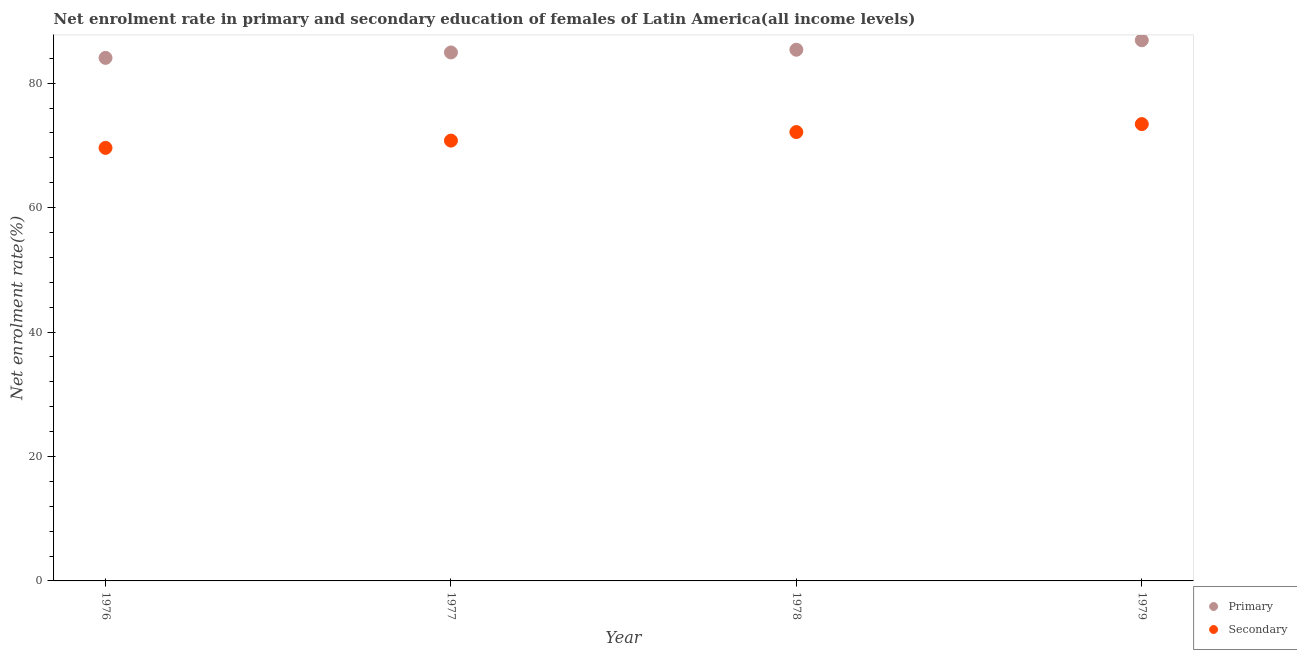Is the number of dotlines equal to the number of legend labels?
Offer a very short reply. Yes. What is the enrollment rate in primary education in 1979?
Offer a terse response. 86.9. Across all years, what is the maximum enrollment rate in secondary education?
Give a very brief answer. 73.43. Across all years, what is the minimum enrollment rate in primary education?
Keep it short and to the point. 84.07. In which year was the enrollment rate in primary education maximum?
Give a very brief answer. 1979. In which year was the enrollment rate in primary education minimum?
Ensure brevity in your answer.  1976. What is the total enrollment rate in secondary education in the graph?
Provide a succinct answer. 285.94. What is the difference between the enrollment rate in primary education in 1976 and that in 1978?
Provide a succinct answer. -1.31. What is the difference between the enrollment rate in secondary education in 1979 and the enrollment rate in primary education in 1977?
Provide a succinct answer. -11.51. What is the average enrollment rate in primary education per year?
Provide a short and direct response. 85.32. In the year 1978, what is the difference between the enrollment rate in primary education and enrollment rate in secondary education?
Keep it short and to the point. 13.23. What is the ratio of the enrollment rate in secondary education in 1976 to that in 1979?
Your response must be concise. 0.95. Is the difference between the enrollment rate in secondary education in 1977 and 1979 greater than the difference between the enrollment rate in primary education in 1977 and 1979?
Provide a short and direct response. No. What is the difference between the highest and the second highest enrollment rate in primary education?
Your answer should be very brief. 1.52. What is the difference between the highest and the lowest enrollment rate in secondary education?
Make the answer very short. 3.82. In how many years, is the enrollment rate in secondary education greater than the average enrollment rate in secondary education taken over all years?
Give a very brief answer. 2. How many years are there in the graph?
Your answer should be very brief. 4. Does the graph contain grids?
Offer a very short reply. No. How many legend labels are there?
Keep it short and to the point. 2. What is the title of the graph?
Make the answer very short. Net enrolment rate in primary and secondary education of females of Latin America(all income levels). Does "Investment in Telecom" appear as one of the legend labels in the graph?
Provide a succinct answer. No. What is the label or title of the X-axis?
Your answer should be compact. Year. What is the label or title of the Y-axis?
Provide a short and direct response. Net enrolment rate(%). What is the Net enrolment rate(%) in Primary in 1976?
Ensure brevity in your answer.  84.07. What is the Net enrolment rate(%) of Secondary in 1976?
Provide a succinct answer. 69.6. What is the Net enrolment rate(%) in Primary in 1977?
Ensure brevity in your answer.  84.94. What is the Net enrolment rate(%) in Secondary in 1977?
Offer a very short reply. 70.77. What is the Net enrolment rate(%) in Primary in 1978?
Offer a very short reply. 85.38. What is the Net enrolment rate(%) in Secondary in 1978?
Ensure brevity in your answer.  72.14. What is the Net enrolment rate(%) in Primary in 1979?
Ensure brevity in your answer.  86.9. What is the Net enrolment rate(%) in Secondary in 1979?
Ensure brevity in your answer.  73.43. Across all years, what is the maximum Net enrolment rate(%) in Primary?
Your answer should be compact. 86.9. Across all years, what is the maximum Net enrolment rate(%) in Secondary?
Your answer should be compact. 73.43. Across all years, what is the minimum Net enrolment rate(%) in Primary?
Ensure brevity in your answer.  84.07. Across all years, what is the minimum Net enrolment rate(%) of Secondary?
Keep it short and to the point. 69.6. What is the total Net enrolment rate(%) of Primary in the graph?
Your answer should be compact. 341.28. What is the total Net enrolment rate(%) in Secondary in the graph?
Provide a succinct answer. 285.94. What is the difference between the Net enrolment rate(%) in Primary in 1976 and that in 1977?
Your answer should be very brief. -0.87. What is the difference between the Net enrolment rate(%) in Secondary in 1976 and that in 1977?
Your answer should be very brief. -1.17. What is the difference between the Net enrolment rate(%) in Primary in 1976 and that in 1978?
Provide a short and direct response. -1.31. What is the difference between the Net enrolment rate(%) of Secondary in 1976 and that in 1978?
Ensure brevity in your answer.  -2.54. What is the difference between the Net enrolment rate(%) of Primary in 1976 and that in 1979?
Your answer should be compact. -2.83. What is the difference between the Net enrolment rate(%) in Secondary in 1976 and that in 1979?
Give a very brief answer. -3.82. What is the difference between the Net enrolment rate(%) in Primary in 1977 and that in 1978?
Your response must be concise. -0.44. What is the difference between the Net enrolment rate(%) in Secondary in 1977 and that in 1978?
Provide a succinct answer. -1.37. What is the difference between the Net enrolment rate(%) of Primary in 1977 and that in 1979?
Your answer should be very brief. -1.96. What is the difference between the Net enrolment rate(%) of Secondary in 1977 and that in 1979?
Your answer should be very brief. -2.65. What is the difference between the Net enrolment rate(%) of Primary in 1978 and that in 1979?
Your response must be concise. -1.52. What is the difference between the Net enrolment rate(%) in Secondary in 1978 and that in 1979?
Your answer should be compact. -1.28. What is the difference between the Net enrolment rate(%) of Primary in 1976 and the Net enrolment rate(%) of Secondary in 1977?
Offer a terse response. 13.3. What is the difference between the Net enrolment rate(%) in Primary in 1976 and the Net enrolment rate(%) in Secondary in 1978?
Make the answer very short. 11.92. What is the difference between the Net enrolment rate(%) in Primary in 1976 and the Net enrolment rate(%) in Secondary in 1979?
Your answer should be compact. 10.64. What is the difference between the Net enrolment rate(%) in Primary in 1977 and the Net enrolment rate(%) in Secondary in 1978?
Your answer should be compact. 12.79. What is the difference between the Net enrolment rate(%) in Primary in 1977 and the Net enrolment rate(%) in Secondary in 1979?
Provide a succinct answer. 11.51. What is the difference between the Net enrolment rate(%) in Primary in 1978 and the Net enrolment rate(%) in Secondary in 1979?
Give a very brief answer. 11.95. What is the average Net enrolment rate(%) in Primary per year?
Offer a very short reply. 85.32. What is the average Net enrolment rate(%) of Secondary per year?
Provide a short and direct response. 71.49. In the year 1976, what is the difference between the Net enrolment rate(%) in Primary and Net enrolment rate(%) in Secondary?
Provide a short and direct response. 14.47. In the year 1977, what is the difference between the Net enrolment rate(%) in Primary and Net enrolment rate(%) in Secondary?
Your answer should be very brief. 14.17. In the year 1978, what is the difference between the Net enrolment rate(%) in Primary and Net enrolment rate(%) in Secondary?
Your answer should be compact. 13.23. In the year 1979, what is the difference between the Net enrolment rate(%) of Primary and Net enrolment rate(%) of Secondary?
Your answer should be very brief. 13.48. What is the ratio of the Net enrolment rate(%) in Secondary in 1976 to that in 1977?
Keep it short and to the point. 0.98. What is the ratio of the Net enrolment rate(%) of Primary in 1976 to that in 1978?
Provide a short and direct response. 0.98. What is the ratio of the Net enrolment rate(%) of Secondary in 1976 to that in 1978?
Keep it short and to the point. 0.96. What is the ratio of the Net enrolment rate(%) of Primary in 1976 to that in 1979?
Offer a terse response. 0.97. What is the ratio of the Net enrolment rate(%) of Secondary in 1976 to that in 1979?
Provide a short and direct response. 0.95. What is the ratio of the Net enrolment rate(%) in Secondary in 1977 to that in 1978?
Your response must be concise. 0.98. What is the ratio of the Net enrolment rate(%) of Primary in 1977 to that in 1979?
Make the answer very short. 0.98. What is the ratio of the Net enrolment rate(%) of Secondary in 1977 to that in 1979?
Your answer should be very brief. 0.96. What is the ratio of the Net enrolment rate(%) of Primary in 1978 to that in 1979?
Give a very brief answer. 0.98. What is the ratio of the Net enrolment rate(%) of Secondary in 1978 to that in 1979?
Provide a short and direct response. 0.98. What is the difference between the highest and the second highest Net enrolment rate(%) of Primary?
Make the answer very short. 1.52. What is the difference between the highest and the second highest Net enrolment rate(%) in Secondary?
Offer a terse response. 1.28. What is the difference between the highest and the lowest Net enrolment rate(%) of Primary?
Provide a short and direct response. 2.83. What is the difference between the highest and the lowest Net enrolment rate(%) in Secondary?
Provide a short and direct response. 3.82. 